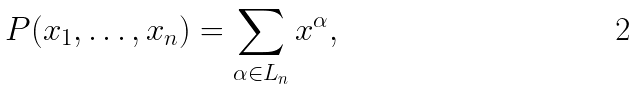<formula> <loc_0><loc_0><loc_500><loc_500>P ( x _ { 1 } , \dots , x _ { n } ) = \sum _ { \alpha \in L _ { n } } x ^ { \alpha } ,</formula> 